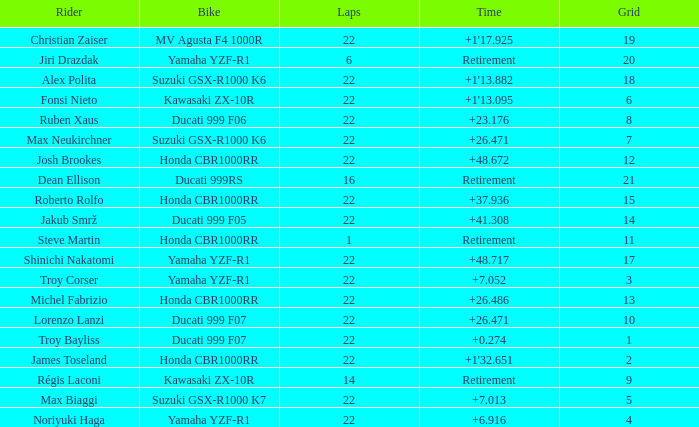When the grid number is 10, what is the total number of laps? 1.0. 